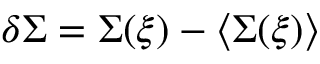<formula> <loc_0><loc_0><loc_500><loc_500>\delta \Sigma = \Sigma ( \xi ) - \langle \Sigma ( \xi ) \rangle</formula> 